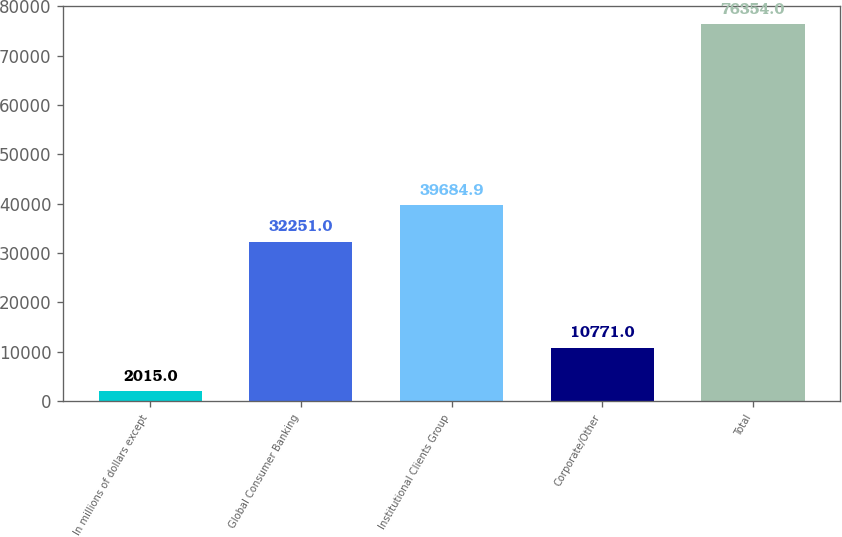<chart> <loc_0><loc_0><loc_500><loc_500><bar_chart><fcel>In millions of dollars except<fcel>Global Consumer Banking<fcel>Institutional Clients Group<fcel>Corporate/Other<fcel>Total<nl><fcel>2015<fcel>32251<fcel>39684.9<fcel>10771<fcel>76354<nl></chart> 